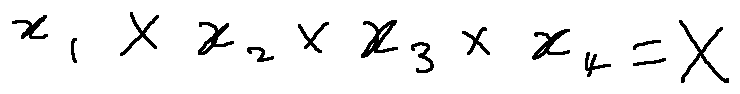Convert formula to latex. <formula><loc_0><loc_0><loc_500><loc_500>x _ { 1 } \times x _ { 2 } \times x _ { 3 } \times x _ { 4 } = X</formula> 